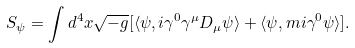Convert formula to latex. <formula><loc_0><loc_0><loc_500><loc_500>S _ { \psi } = \int d ^ { 4 } x \sqrt { - g } [ \langle \psi , i \gamma ^ { 0 } \gamma ^ { \mu } D _ { \mu } \psi \rangle + \langle \psi , m i \gamma ^ { 0 } \psi \rangle ] .</formula> 